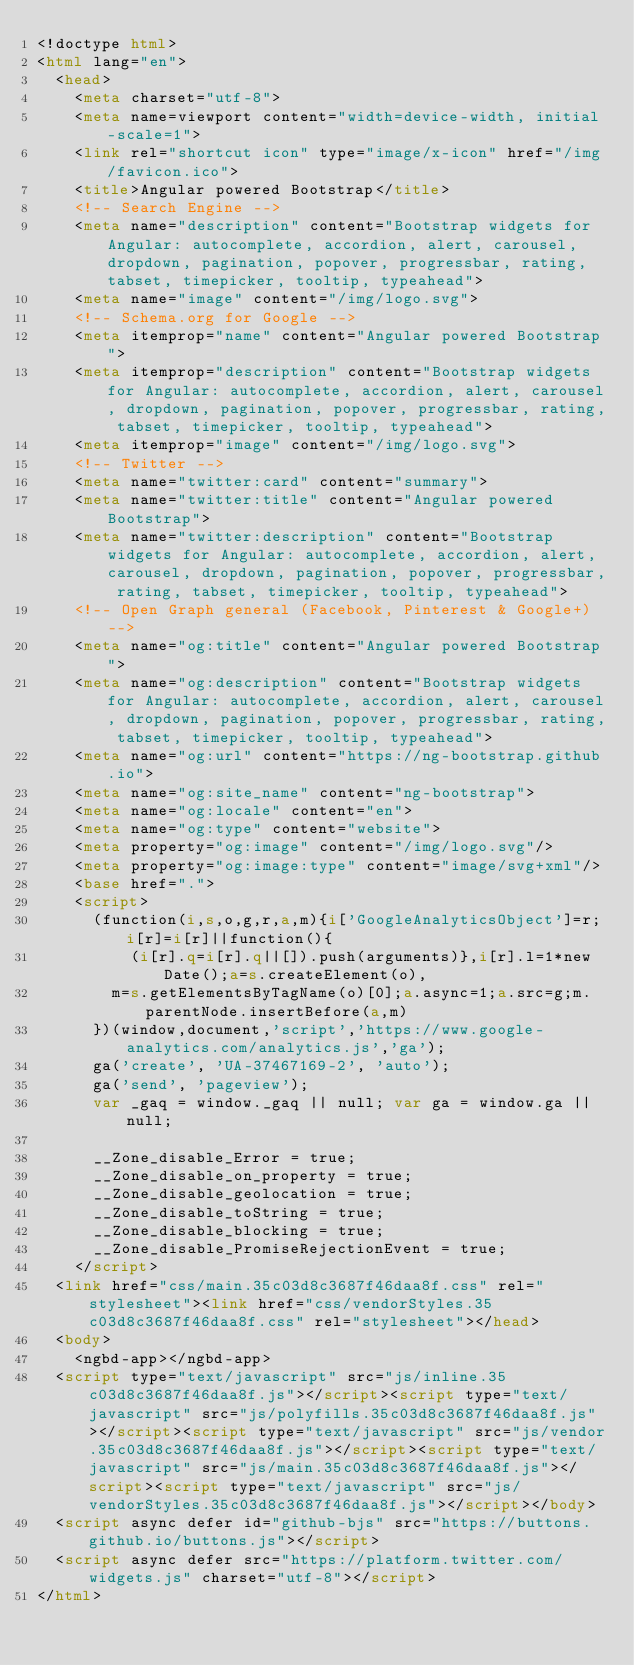<code> <loc_0><loc_0><loc_500><loc_500><_HTML_><!doctype html>
<html lang="en">
  <head>
    <meta charset="utf-8">
    <meta name=viewport content="width=device-width, initial-scale=1">
    <link rel="shortcut icon" type="image/x-icon" href="/img/favicon.ico">
    <title>Angular powered Bootstrap</title>
    <!-- Search Engine -->
    <meta name="description" content="Bootstrap widgets for Angular: autocomplete, accordion, alert, carousel, dropdown, pagination, popover, progressbar, rating, tabset, timepicker, tooltip, typeahead">
    <meta name="image" content="/img/logo.svg">
    <!-- Schema.org for Google -->
    <meta itemprop="name" content="Angular powered Bootstrap">
    <meta itemprop="description" content="Bootstrap widgets for Angular: autocomplete, accordion, alert, carousel, dropdown, pagination, popover, progressbar, rating, tabset, timepicker, tooltip, typeahead">
    <meta itemprop="image" content="/img/logo.svg">
    <!-- Twitter -->
    <meta name="twitter:card" content="summary">
    <meta name="twitter:title" content="Angular powered Bootstrap">
    <meta name="twitter:description" content="Bootstrap widgets for Angular: autocomplete, accordion, alert, carousel, dropdown, pagination, popover, progressbar, rating, tabset, timepicker, tooltip, typeahead">
    <!-- Open Graph general (Facebook, Pinterest & Google+) -->
    <meta name="og:title" content="Angular powered Bootstrap">
    <meta name="og:description" content="Bootstrap widgets for Angular: autocomplete, accordion, alert, carousel, dropdown, pagination, popover, progressbar, rating, tabset, timepicker, tooltip, typeahead">
    <meta name="og:url" content="https://ng-bootstrap.github.io">
    <meta name="og:site_name" content="ng-bootstrap">
    <meta name="og:locale" content="en">
    <meta name="og:type" content="website">
    <meta property="og:image" content="/img/logo.svg"/>
    <meta property="og:image:type" content="image/svg+xml"/>
    <base href=".">
    <script>
      (function(i,s,o,g,r,a,m){i['GoogleAnalyticsObject']=r;i[r]=i[r]||function(){
          (i[r].q=i[r].q||[]).push(arguments)},i[r].l=1*new Date();a=s.createElement(o),
        m=s.getElementsByTagName(o)[0];a.async=1;a.src=g;m.parentNode.insertBefore(a,m)
      })(window,document,'script','https://www.google-analytics.com/analytics.js','ga');
      ga('create', 'UA-37467169-2', 'auto');
      ga('send', 'pageview');
      var _gaq = window._gaq || null; var ga = window.ga || null;

      __Zone_disable_Error = true;
      __Zone_disable_on_property = true;
      __Zone_disable_geolocation = true;
      __Zone_disable_toString = true;
      __Zone_disable_blocking = true;
      __Zone_disable_PromiseRejectionEvent = true;
    </script>
  <link href="css/main.35c03d8c3687f46daa8f.css" rel="stylesheet"><link href="css/vendorStyles.35c03d8c3687f46daa8f.css" rel="stylesheet"></head>
  <body>
    <ngbd-app></ngbd-app>
  <script type="text/javascript" src="js/inline.35c03d8c3687f46daa8f.js"></script><script type="text/javascript" src="js/polyfills.35c03d8c3687f46daa8f.js"></script><script type="text/javascript" src="js/vendor.35c03d8c3687f46daa8f.js"></script><script type="text/javascript" src="js/main.35c03d8c3687f46daa8f.js"></script><script type="text/javascript" src="js/vendorStyles.35c03d8c3687f46daa8f.js"></script></body>
  <script async defer id="github-bjs" src="https://buttons.github.io/buttons.js"></script>
  <script async defer src="https://platform.twitter.com/widgets.js" charset="utf-8"></script>
</html>
</code> 